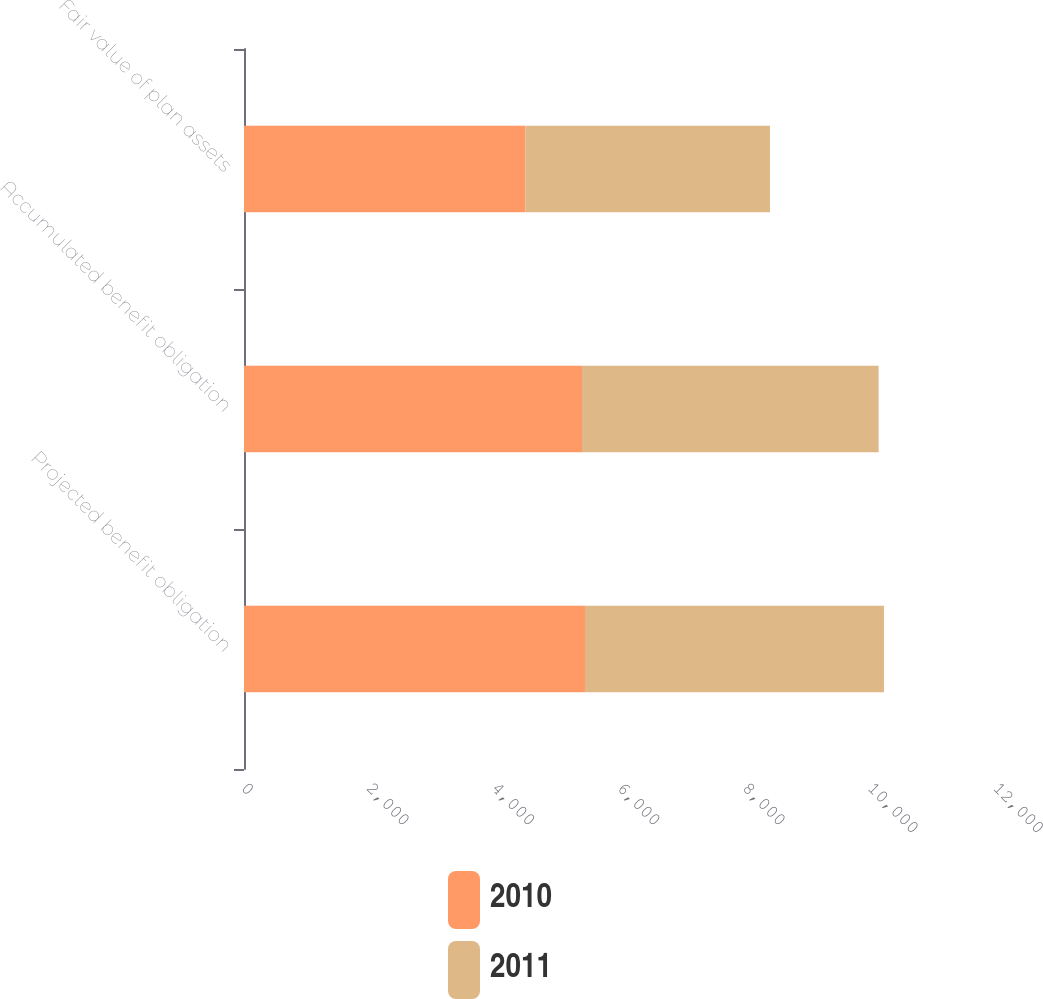<chart> <loc_0><loc_0><loc_500><loc_500><stacked_bar_chart><ecel><fcel>Projected benefit obligation<fcel>Accumulated benefit obligation<fcel>Fair value of plan assets<nl><fcel>2010<fcel>5441<fcel>5394<fcel>4492<nl><fcel>2011<fcel>4771<fcel>4733<fcel>3901<nl></chart> 